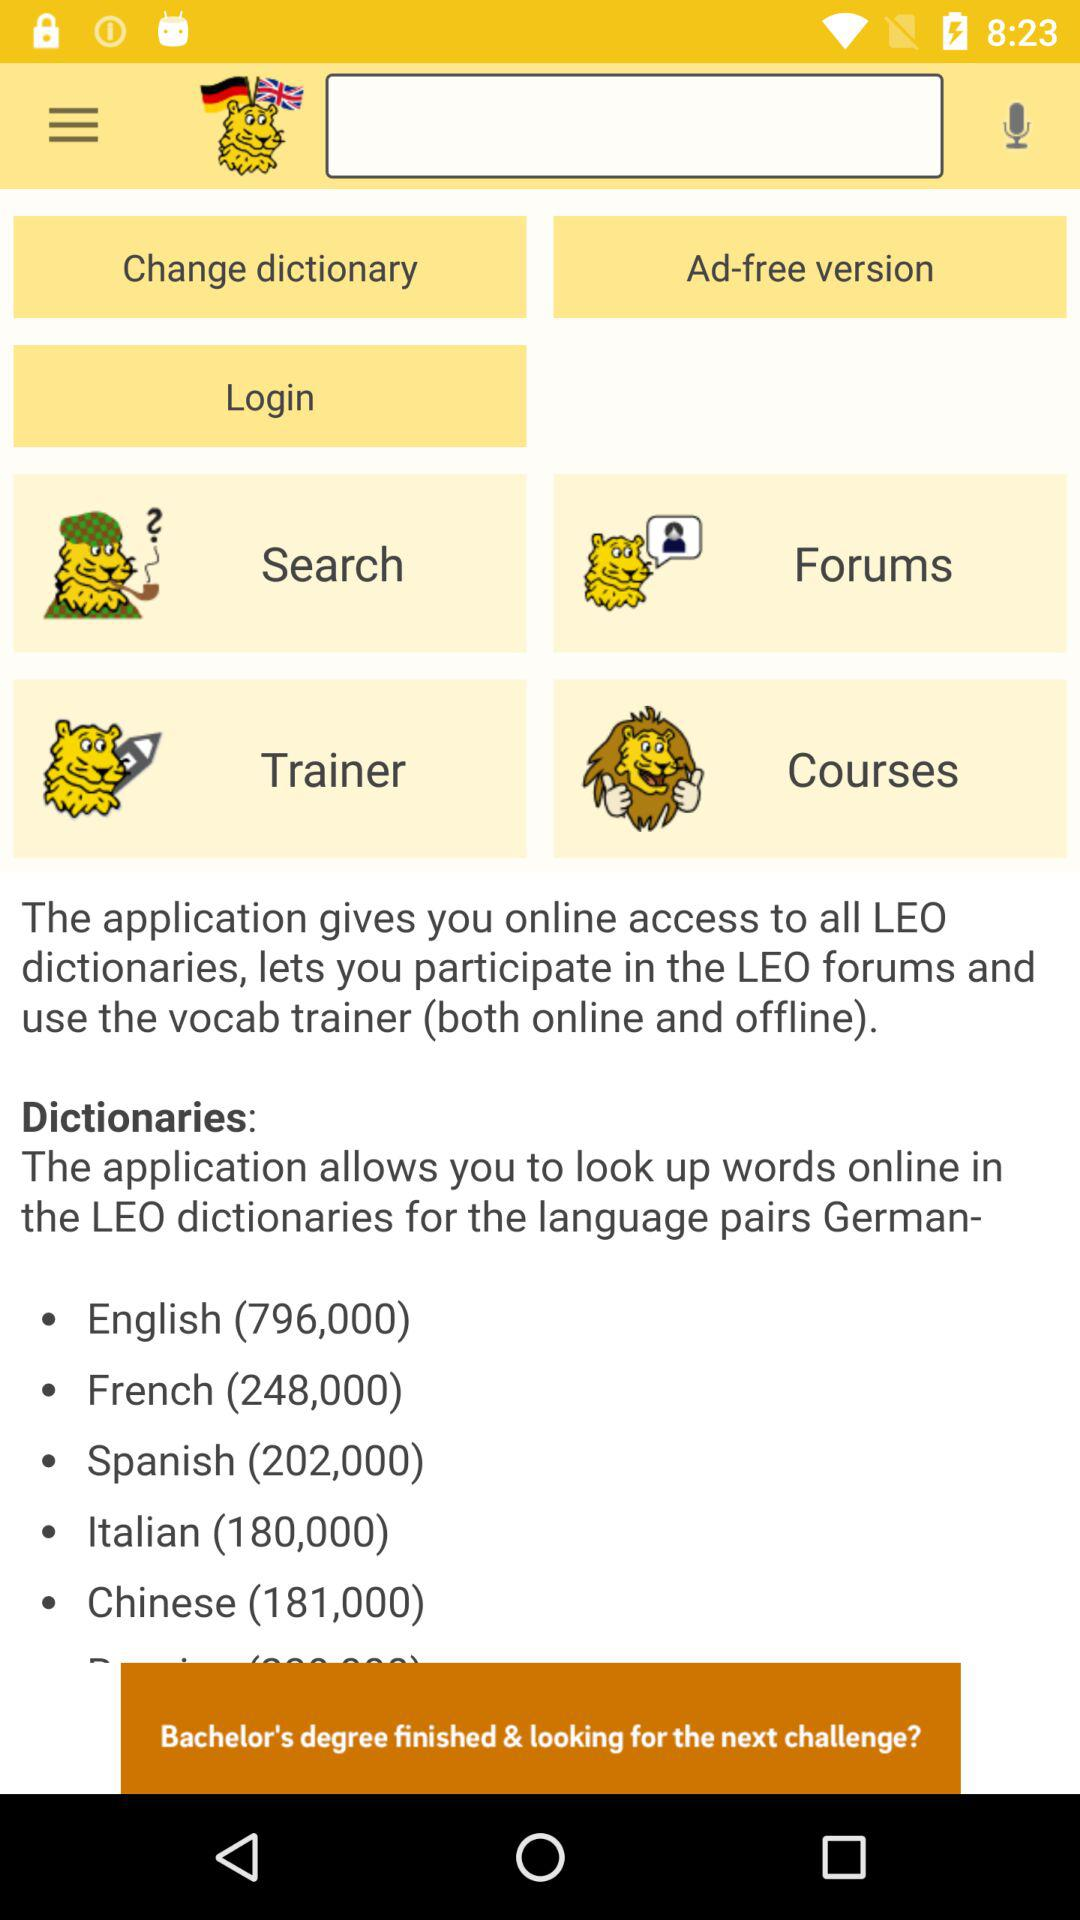180,000 words are in which language? 180,000 words are in Italian language. 